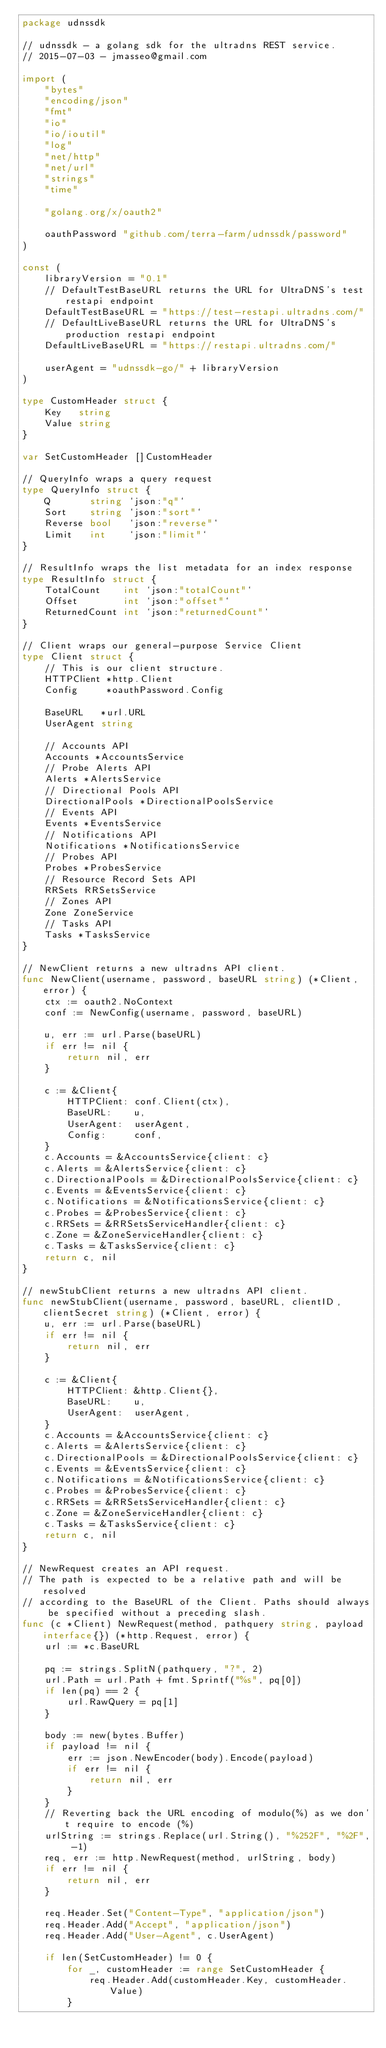<code> <loc_0><loc_0><loc_500><loc_500><_Go_>package udnssdk

// udnssdk - a golang sdk for the ultradns REST service.
// 2015-07-03 - jmasseo@gmail.com

import (
	"bytes"
	"encoding/json"
	"fmt"
	"io"
	"io/ioutil"
	"log"
	"net/http"
	"net/url"
	"strings"
	"time"

	"golang.org/x/oauth2"

	oauthPassword "github.com/terra-farm/udnssdk/password"
)

const (
	libraryVersion = "0.1"
	// DefaultTestBaseURL returns the URL for UltraDNS's test restapi endpoint
	DefaultTestBaseURL = "https://test-restapi.ultradns.com/"
	// DefaultLiveBaseURL returns the URL for UltraDNS's production restapi endpoint
	DefaultLiveBaseURL = "https://restapi.ultradns.com/"

	userAgent = "udnssdk-go/" + libraryVersion
)

type CustomHeader struct {
	Key   string
	Value string
}

var SetCustomHeader []CustomHeader

// QueryInfo wraps a query request
type QueryInfo struct {
	Q       string `json:"q"`
	Sort    string `json:"sort"`
	Reverse bool   `json:"reverse"`
	Limit   int    `json:"limit"`
}

// ResultInfo wraps the list metadata for an index response
type ResultInfo struct {
	TotalCount    int `json:"totalCount"`
	Offset        int `json:"offset"`
	ReturnedCount int `json:"returnedCount"`
}

// Client wraps our general-purpose Service Client
type Client struct {
	// This is our client structure.
	HTTPClient *http.Client
	Config     *oauthPassword.Config

	BaseURL   *url.URL
	UserAgent string

	// Accounts API
	Accounts *AccountsService
	// Probe Alerts API
	Alerts *AlertsService
	// Directional Pools API
	DirectionalPools *DirectionalPoolsService
	// Events API
	Events *EventsService
	// Notifications API
	Notifications *NotificationsService
	// Probes API
	Probes *ProbesService
	// Resource Record Sets API
	RRSets RRSetsService
	// Zones API
	Zone ZoneService
	// Tasks API
	Tasks *TasksService
}

// NewClient returns a new ultradns API client.
func NewClient(username, password, baseURL string) (*Client, error) {
	ctx := oauth2.NoContext
	conf := NewConfig(username, password, baseURL)

	u, err := url.Parse(baseURL)
	if err != nil {
		return nil, err
	}

	c := &Client{
		HTTPClient: conf.Client(ctx),
		BaseURL:    u,
		UserAgent:  userAgent,
		Config:     conf,
	}
	c.Accounts = &AccountsService{client: c}
	c.Alerts = &AlertsService{client: c}
	c.DirectionalPools = &DirectionalPoolsService{client: c}
	c.Events = &EventsService{client: c}
	c.Notifications = &NotificationsService{client: c}
	c.Probes = &ProbesService{client: c}
	c.RRSets = &RRSetsServiceHandler{client: c}
	c.Zone = &ZoneServiceHandler{client: c}
	c.Tasks = &TasksService{client: c}
	return c, nil
}

// newStubClient returns a new ultradns API client.
func newStubClient(username, password, baseURL, clientID, clientSecret string) (*Client, error) {
	u, err := url.Parse(baseURL)
	if err != nil {
		return nil, err
	}

	c := &Client{
		HTTPClient: &http.Client{},
		BaseURL:    u,
		UserAgent:  userAgent,
	}
	c.Accounts = &AccountsService{client: c}
	c.Alerts = &AlertsService{client: c}
	c.DirectionalPools = &DirectionalPoolsService{client: c}
	c.Events = &EventsService{client: c}
	c.Notifications = &NotificationsService{client: c}
	c.Probes = &ProbesService{client: c}
	c.RRSets = &RRSetsServiceHandler{client: c}
	c.Zone = &ZoneServiceHandler{client: c}
	c.Tasks = &TasksService{client: c}
	return c, nil
}

// NewRequest creates an API request.
// The path is expected to be a relative path and will be resolved
// according to the BaseURL of the Client. Paths should always be specified without a preceding slash.
func (c *Client) NewRequest(method, pathquery string, payload interface{}) (*http.Request, error) {
	url := *c.BaseURL

	pq := strings.SplitN(pathquery, "?", 2)
	url.Path = url.Path + fmt.Sprintf("%s", pq[0])
	if len(pq) == 2 {
		url.RawQuery = pq[1]
	}

	body := new(bytes.Buffer)
	if payload != nil {
		err := json.NewEncoder(body).Encode(payload)
		if err != nil {
			return nil, err
		}
	}
	// Reverting back the URL encoding of modulo(%) as we don't require to encode (%)
	urlString := strings.Replace(url.String(), "%252F", "%2F", -1)
	req, err := http.NewRequest(method, urlString, body)
	if err != nil {
		return nil, err
	}

	req.Header.Set("Content-Type", "application/json")
	req.Header.Add("Accept", "application/json")
	req.Header.Add("User-Agent", c.UserAgent)

	if len(SetCustomHeader) != 0 {
		for _, customHeader := range SetCustomHeader {
			req.Header.Add(customHeader.Key, customHeader.Value)
		}</code> 